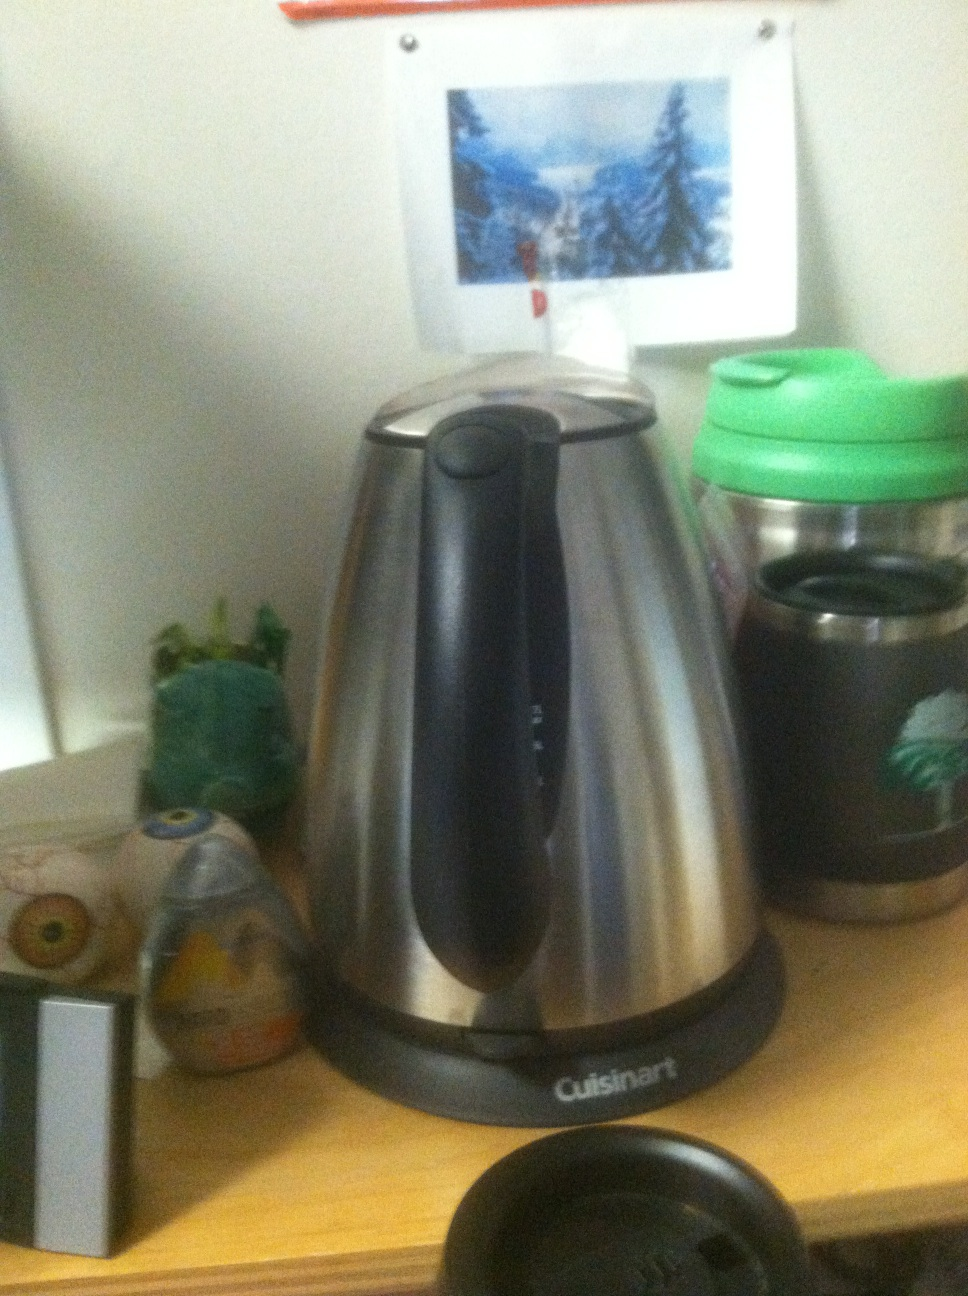Can you tell me more about its features and how it differs from other coffee makers? This Cuisinart coffee pot likely includes multiple settings such as temperature control and an automatic shut-off feature. The stainless steel exterior not only gives it a modern look but also makes it more durable compared to other models often made with plastic components. How should it be properly maintained? Regular maintenance should include descaling to remove mineral buildup, cleaning the coffee basket and carafe after each use, and wiping down the exterior to keep it looking new. Using vinegar and water for descaling is a common and effective method. 